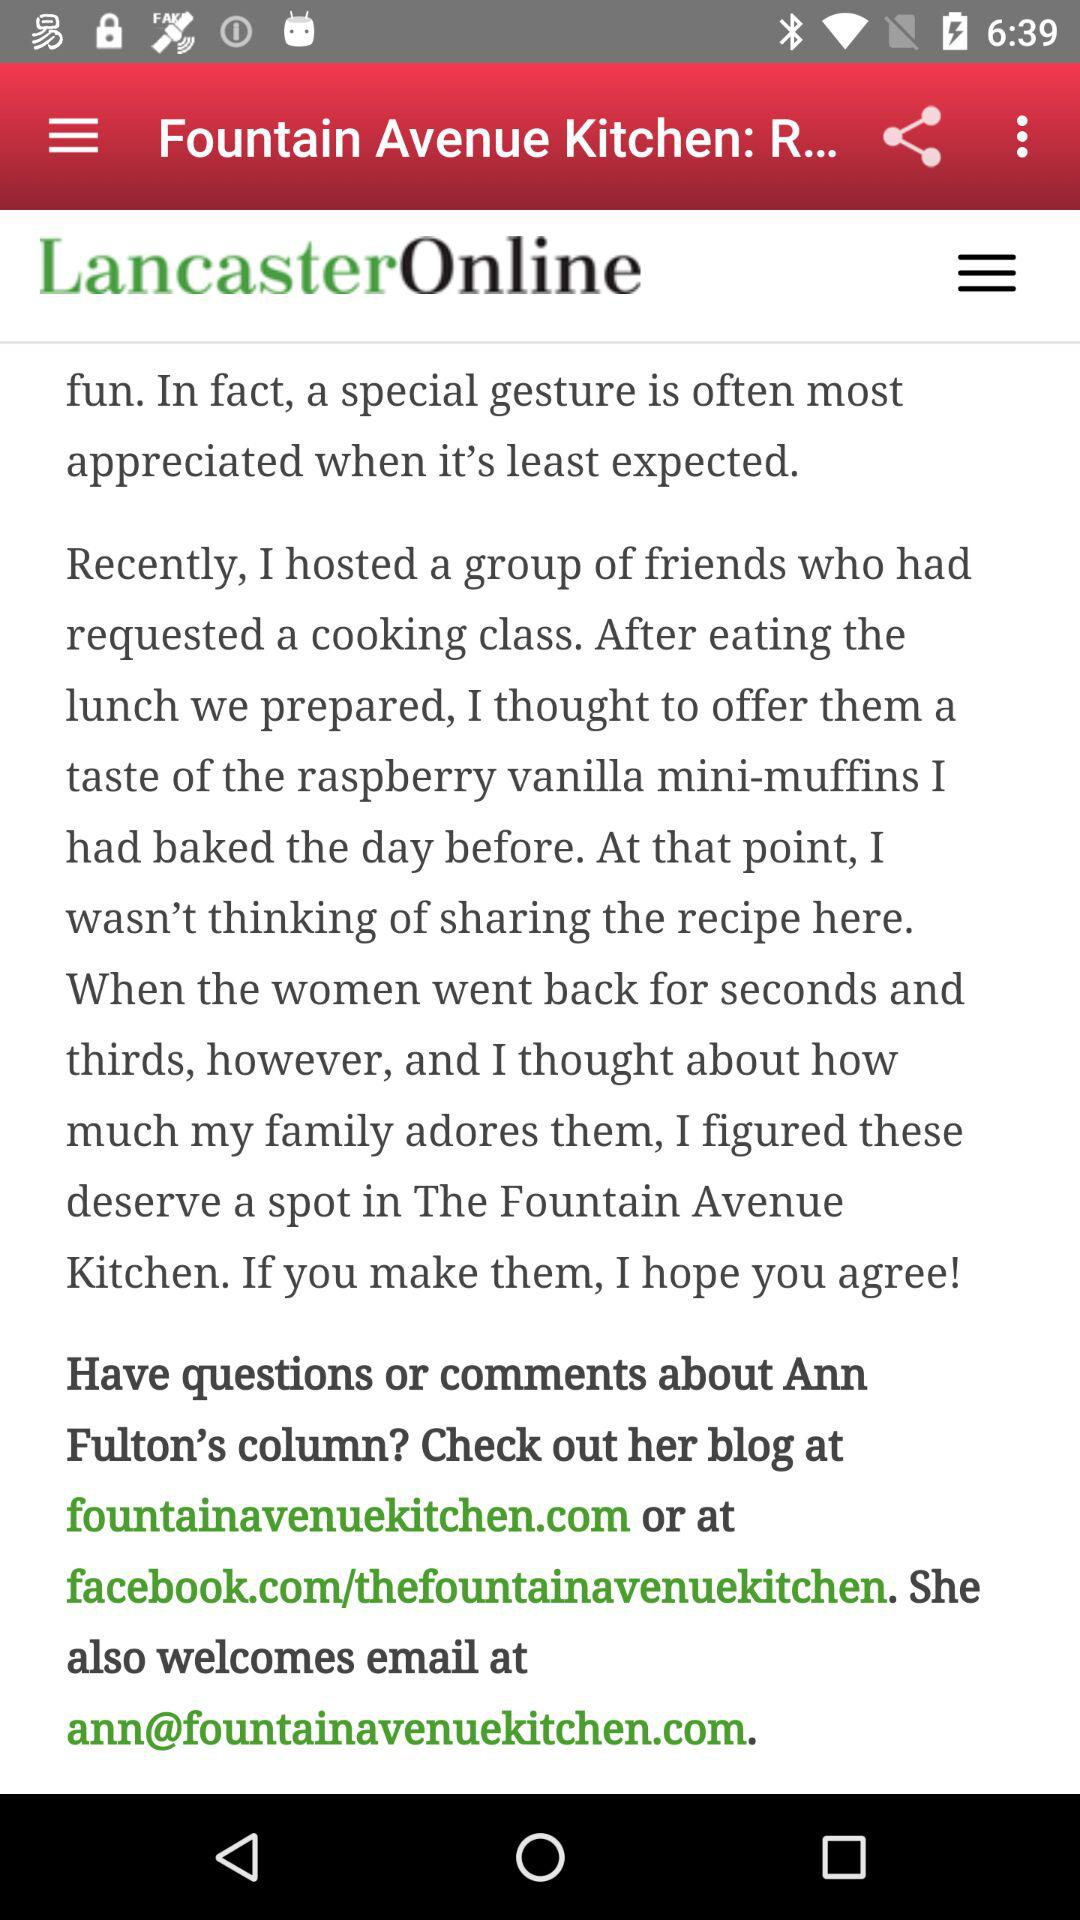What is the email address? The email address is ann@fountainavenuekitchen.com. 